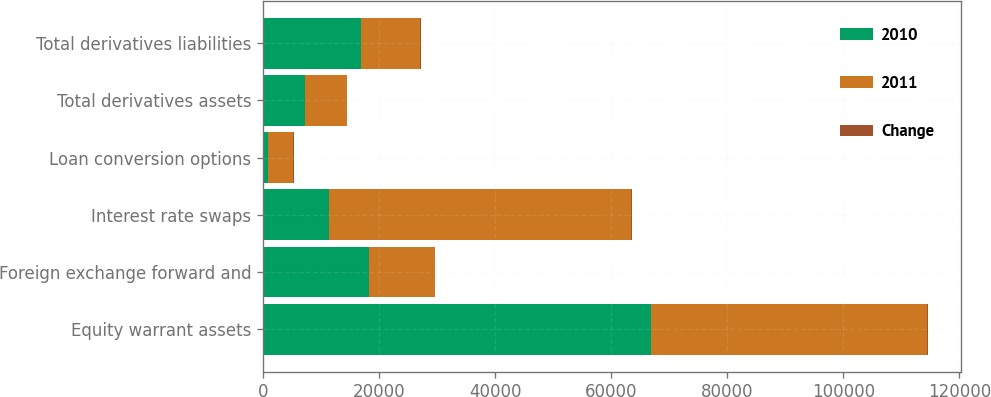Convert chart. <chart><loc_0><loc_0><loc_500><loc_500><stacked_bar_chart><ecel><fcel>Equity warrant assets<fcel>Foreign exchange forward and<fcel>Interest rate swaps<fcel>Loan conversion options<fcel>Total derivatives assets<fcel>Total derivatives liabilities<nl><fcel>2010<fcel>66953<fcel>18326<fcel>11441<fcel>923<fcel>7279<fcel>16868<nl><fcel>2011<fcel>47565<fcel>11349<fcel>52017<fcel>4291<fcel>7279<fcel>10267<nl><fcel>Change<fcel>40.8<fcel>61.5<fcel>78<fcel>78.5<fcel>15.2<fcel>64.3<nl></chart> 